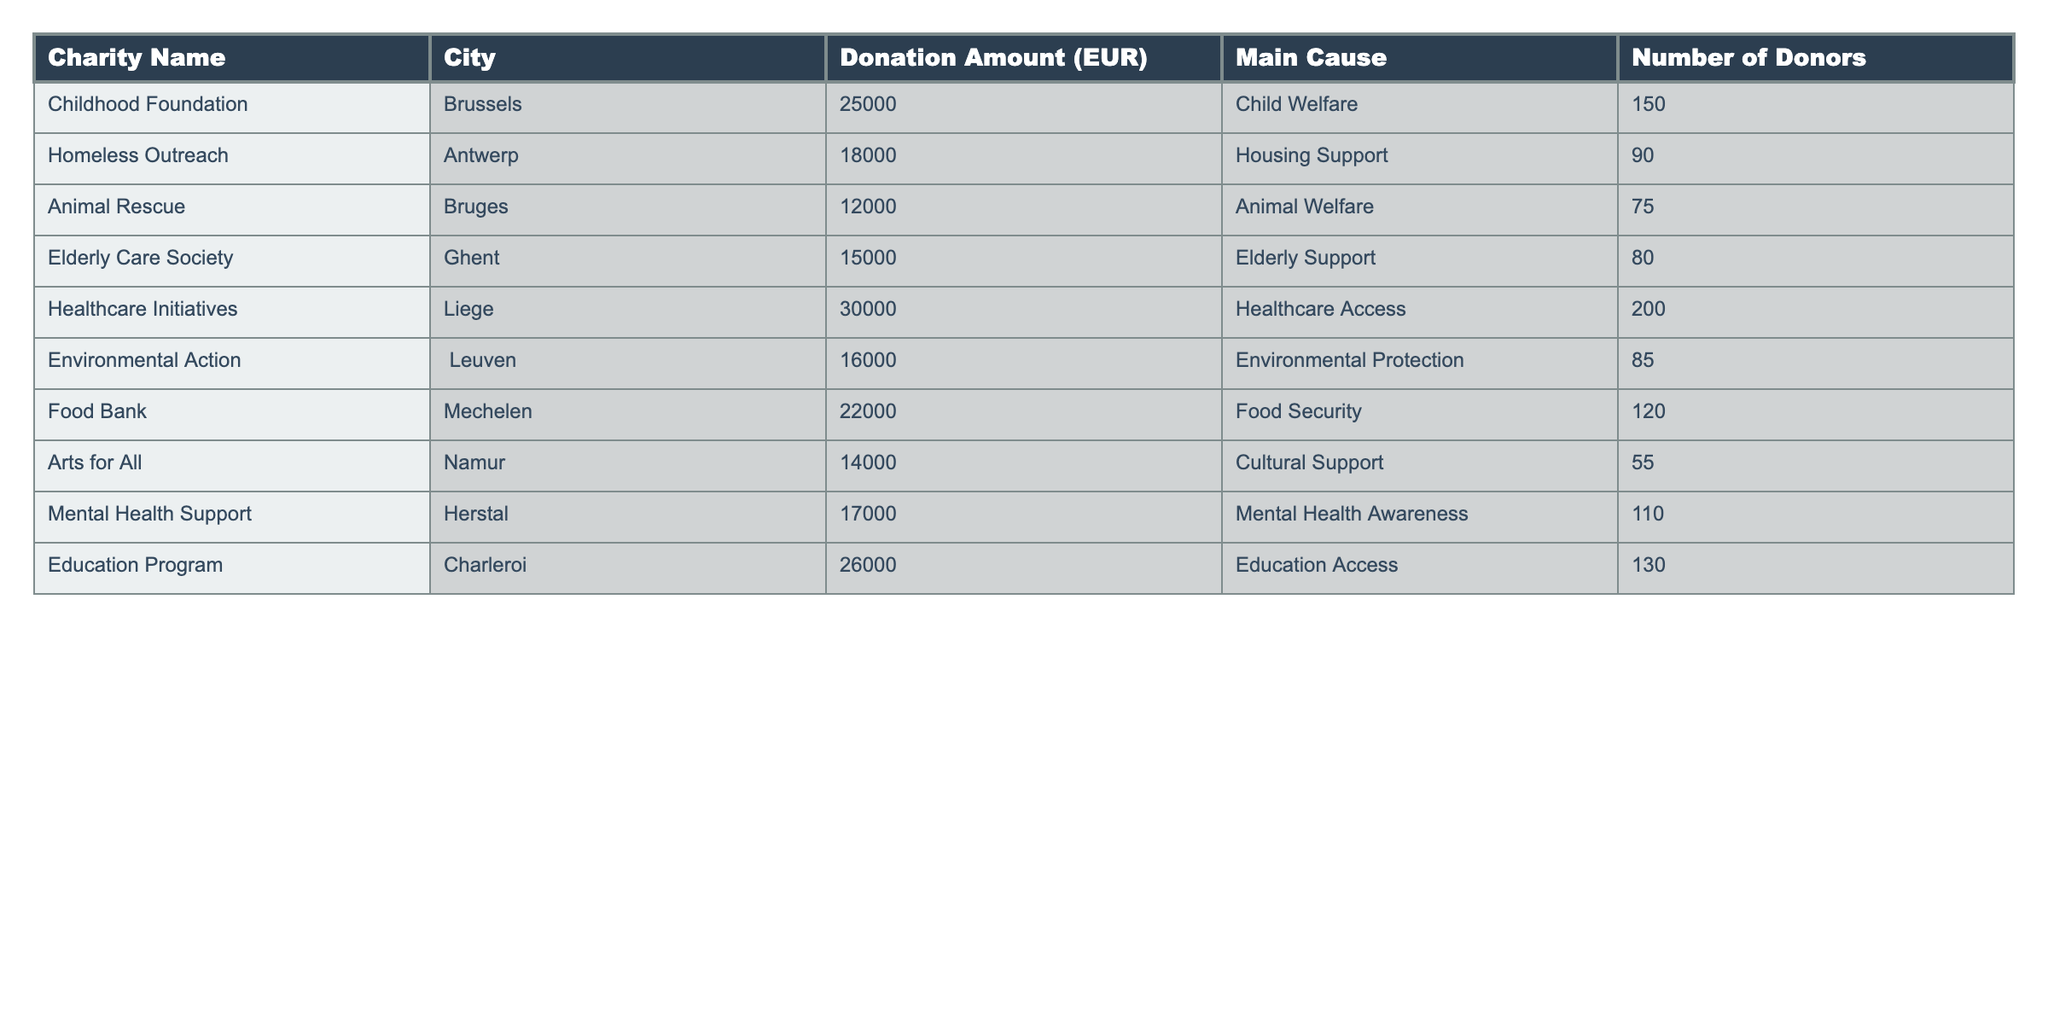What is the highest donation amount collected? The table shows the donation amounts for various charities. By scanning through the "Donation Amount (EUR)" column, we see that the highest amount is 30000 EUR, contributed to the Healthcare Initiatives in Liege.
Answer: 30000 EUR What is the total amount donated to charities focused on welfare (Child, Animal, and Elderly)? To find the total, we add the donation amounts for each relevant charity: Childhood Foundation (25000 EUR) + Animal Rescue (12000 EUR) + Elderly Care Society (15000 EUR) = 52000 EUR.
Answer: 52000 EUR How many donors contributed to the Food Bank? By looking at the "Number of Donors" column next to the Food Bank charity, we see that there were 120 donors.
Answer: 120 Which city received the least amount of donations? By comparing the donation amounts from different cities, we find that Bruges, with a donation of 12000 EUR for Animal Rescue, received the least.
Answer: Bruges Is there any charity focused on Environmental Protection? Yes, the "Main Cause" column lists Environmental Action as focused on Environmental Protection, and it raised 16000 EUR.
Answer: Yes What is the average donation amount for all charities listed? To find the average, we first sum all donation amounts: 25000 + 18000 + 12000 + 15000 + 30000 + 16000 + 22000 + 14000 + 17000 + 26000 = 221000 EUR. There are 10 charities, so the average is 221000 / 10 = 22100 EUR.
Answer: 22100 EUR How many donors contributed to the Healthcare Initiatives, and did they donate the highest amount? The Healthcare Initiatives had 200 donors and collected the highest amount at 30000 EUR, which confirms that this charity attracted the most donors and donations.
Answer: Yes Which charity had more donors: the Food Bank or the Mental Health Support? The Food Bank had 120 donors while Mental Health Support had 110 donors. Thus, Food Bank had more donors.
Answer: Food Bank What percentage of the total donations came from the Education Program? First, we calculate the total donation amount which is 221000 EUR (from the earlier calculation). The Education Program raised 26000 EUR. We then find the percentage: (26000 / 221000) * 100 ≈ 11.77%.
Answer: 11.77% Are there more donors for the Animal Welfare charities than Elderly Support charities? Animal Rescue received 75 donors (Animal Welfare) and Elderly Care Society had 80 donors (Elderly Support). Therefore, there were more donors for Elderly Support.
Answer: No What is the difference in donation amounts between Healthcare Initiatives and Education Program? The Healthcare Initiatives collected 30000 EUR, while the Education Program raised 26000 EUR. The difference is 30000 - 26000 = 4000 EUR.
Answer: 4000 EUR 